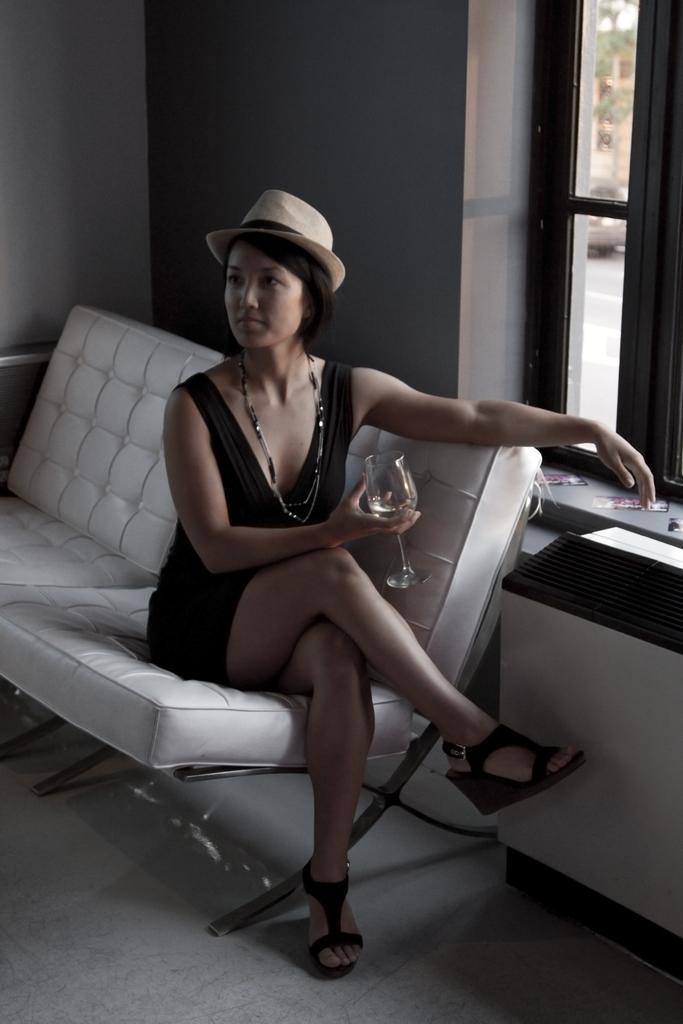In one or two sentences, can you explain what this image depicts? This image consist of a woman wearing black dress and a hat. She is sitting on a white sofa. At the bottom, there is a floor. To the right, there is a window. In the background, there is a wall. 